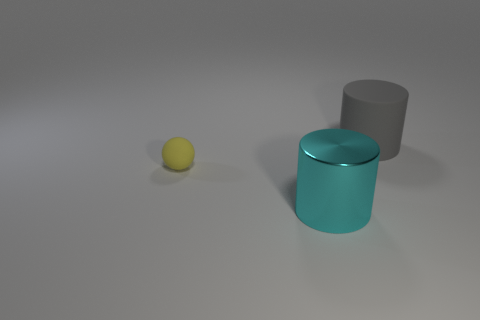How many things are either large things in front of the tiny matte object or small cyan metal blocks?
Ensure brevity in your answer.  1. How many metallic cylinders are in front of the rubber object that is behind the matte ball?
Your response must be concise. 1. Is the number of gray rubber cylinders behind the large gray matte cylinder less than the number of things that are on the right side of the ball?
Offer a very short reply. Yes. What shape is the thing that is in front of the matte object that is left of the big cyan thing?
Provide a short and direct response. Cylinder. What number of other objects are the same material as the big cyan cylinder?
Your answer should be very brief. 0. Is there any other thing that is the same size as the matte sphere?
Your response must be concise. No. Are there more matte things than tiny gray things?
Offer a terse response. Yes. There is a cylinder that is behind the thing in front of the tiny matte object that is in front of the gray cylinder; how big is it?
Keep it short and to the point. Large. There is a cyan cylinder; is it the same size as the cylinder behind the small ball?
Keep it short and to the point. Yes. Is the number of yellow matte things behind the large gray object less than the number of large cyan objects?
Your answer should be compact. Yes. 